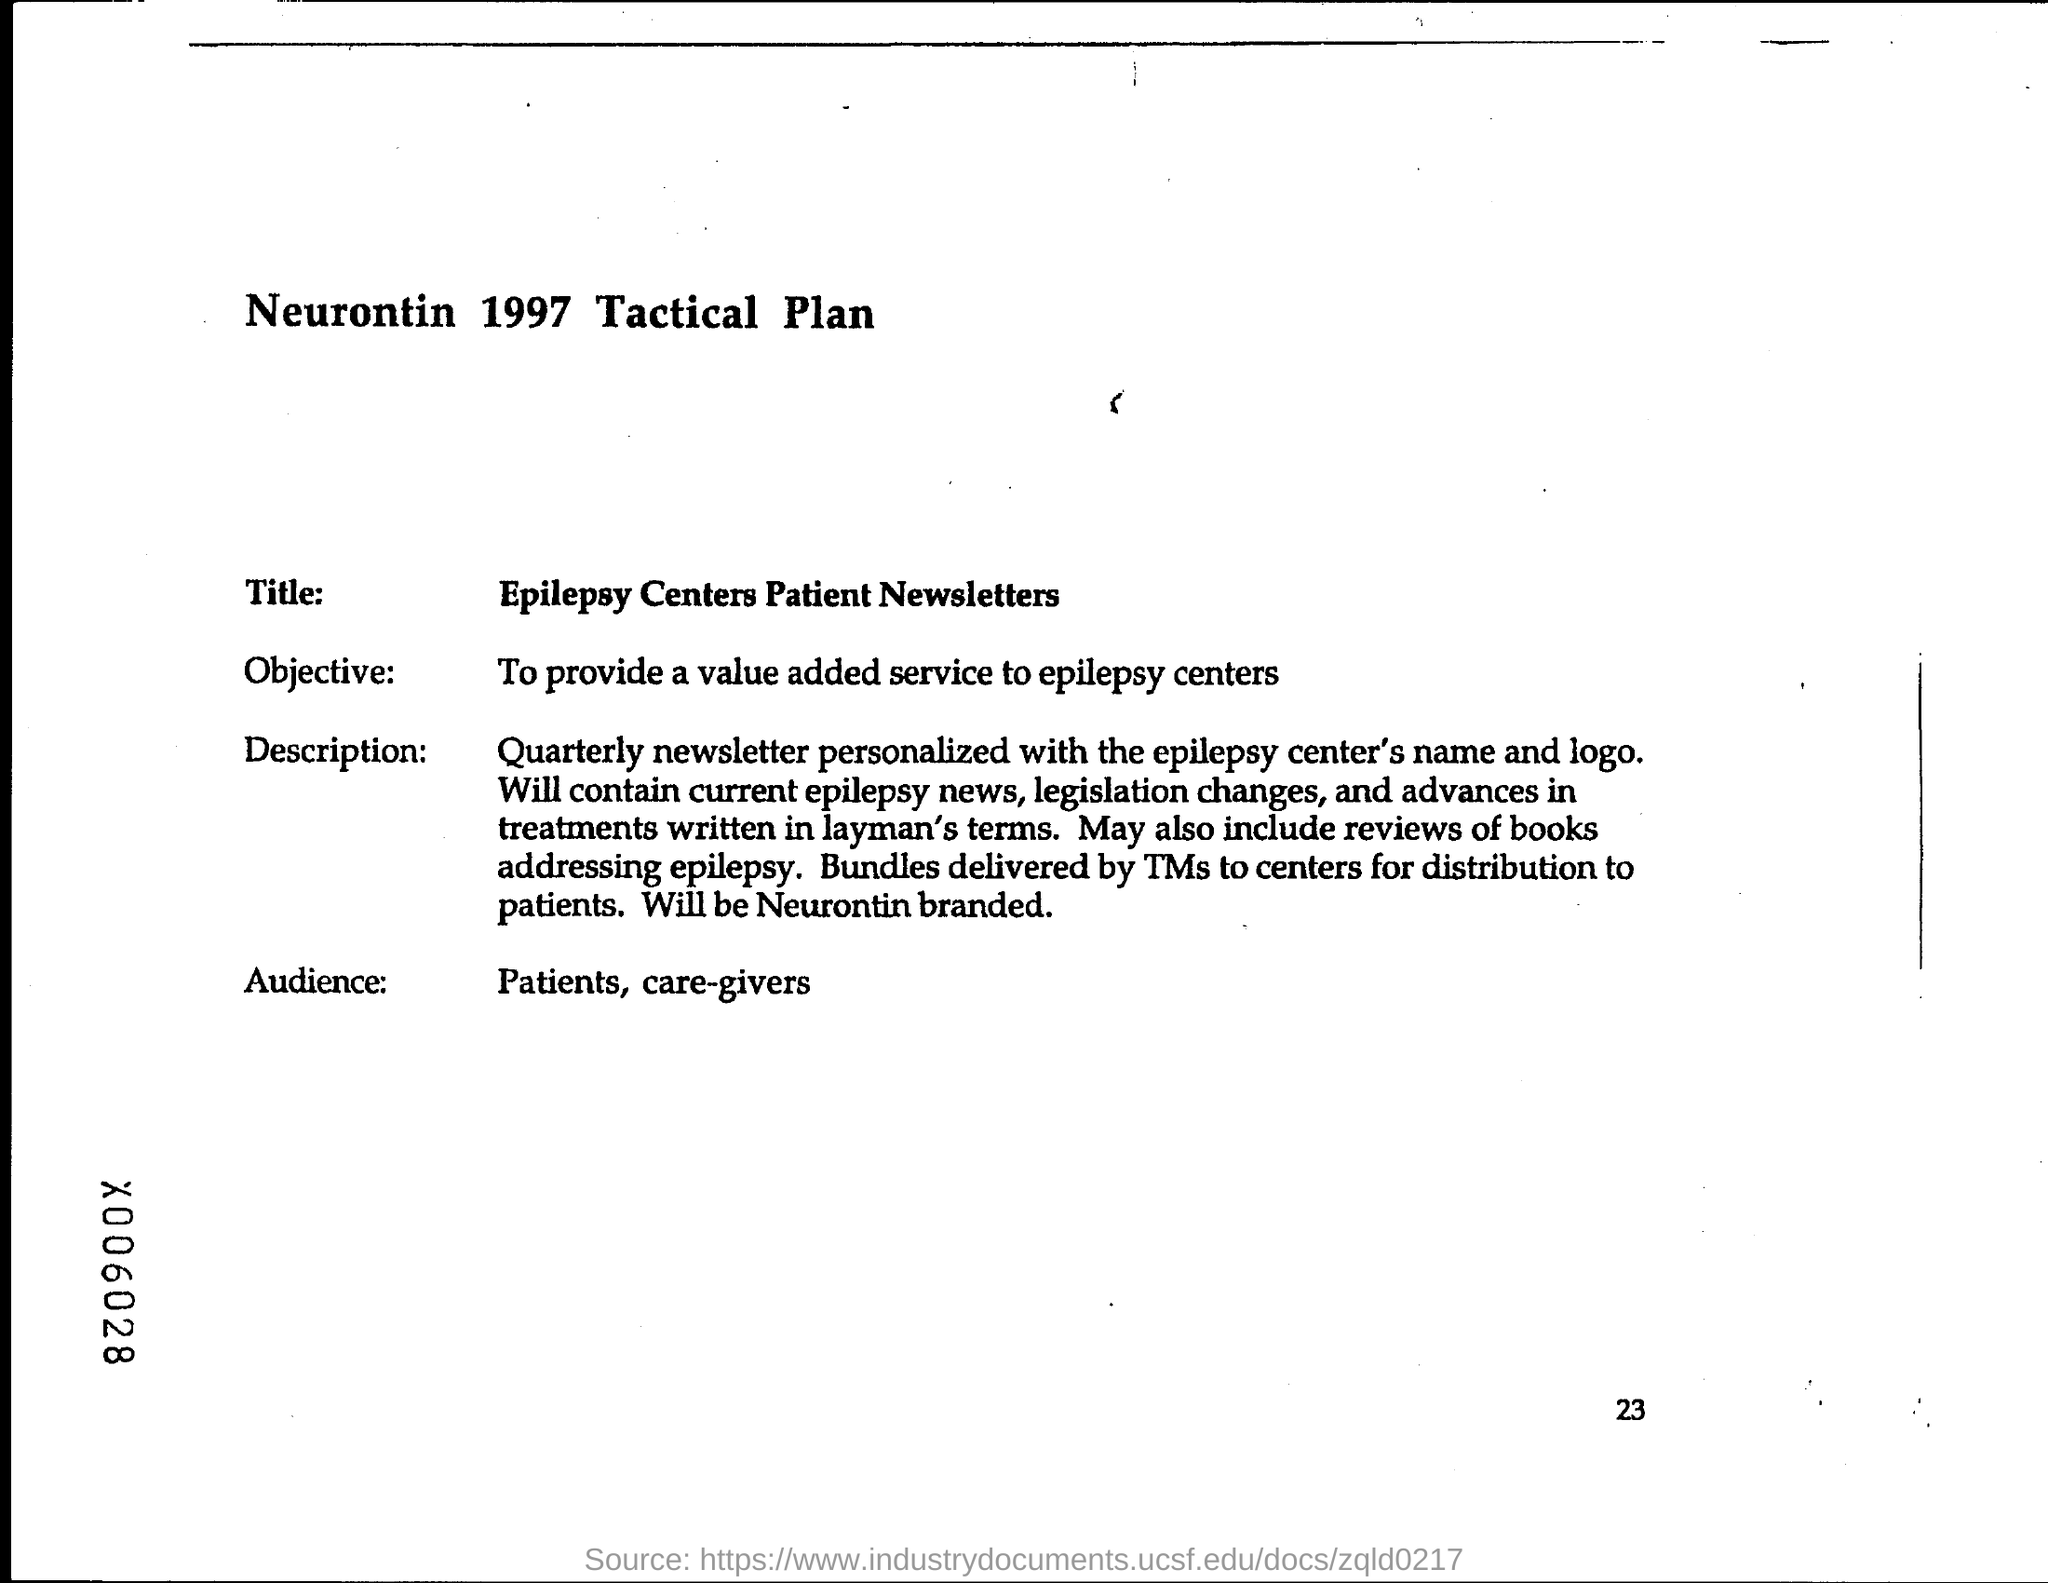What is the heading at top of the page ?
Your response must be concise. Neurontin 1997 Tactical Plan. What is the page number at bottom of the page?
Offer a terse response. 23. 